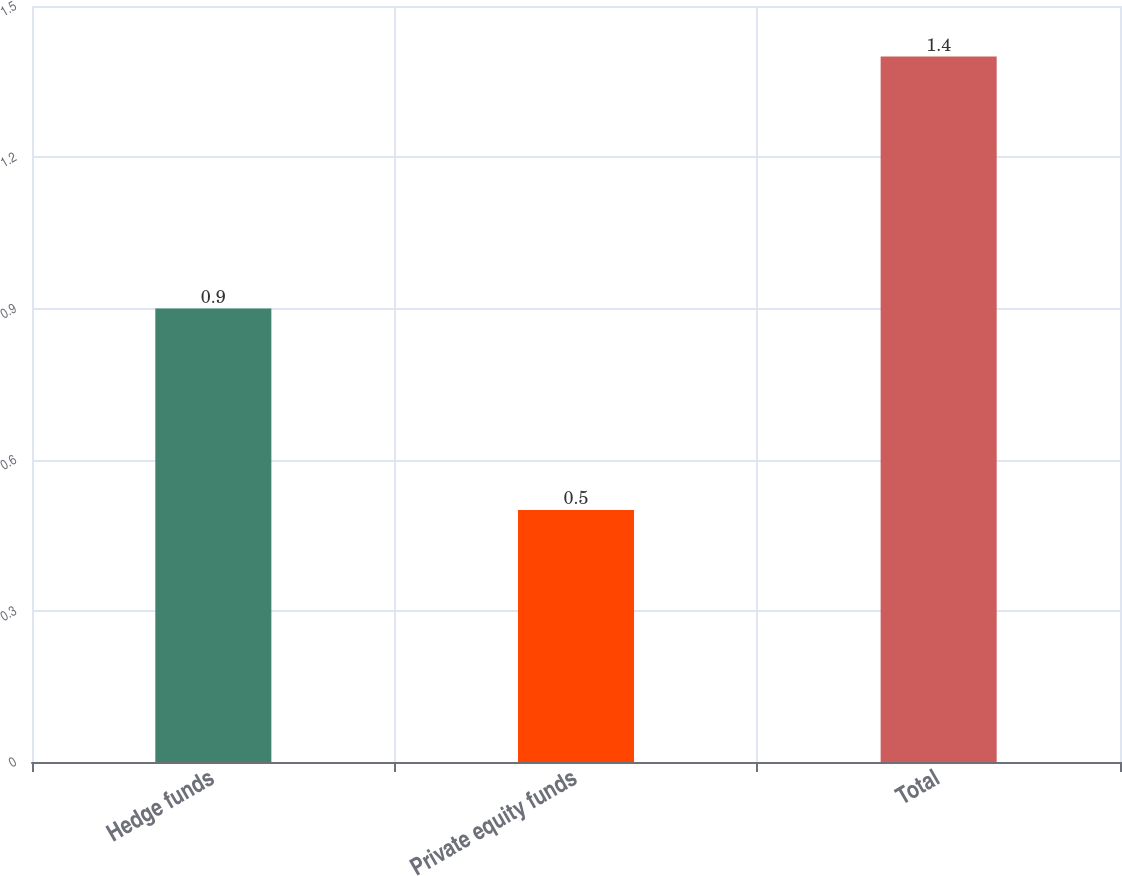Convert chart. <chart><loc_0><loc_0><loc_500><loc_500><bar_chart><fcel>Hedge funds<fcel>Private equity funds<fcel>Total<nl><fcel>0.9<fcel>0.5<fcel>1.4<nl></chart> 